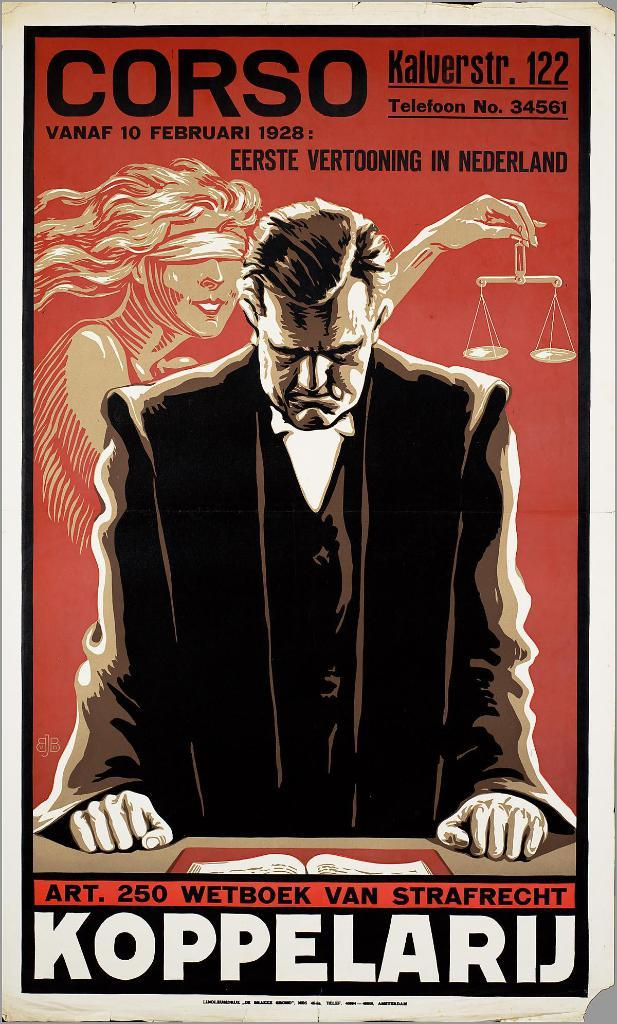<image>
Relay a brief, clear account of the picture shown. The movie Corso premiered on February 10, 1928. 